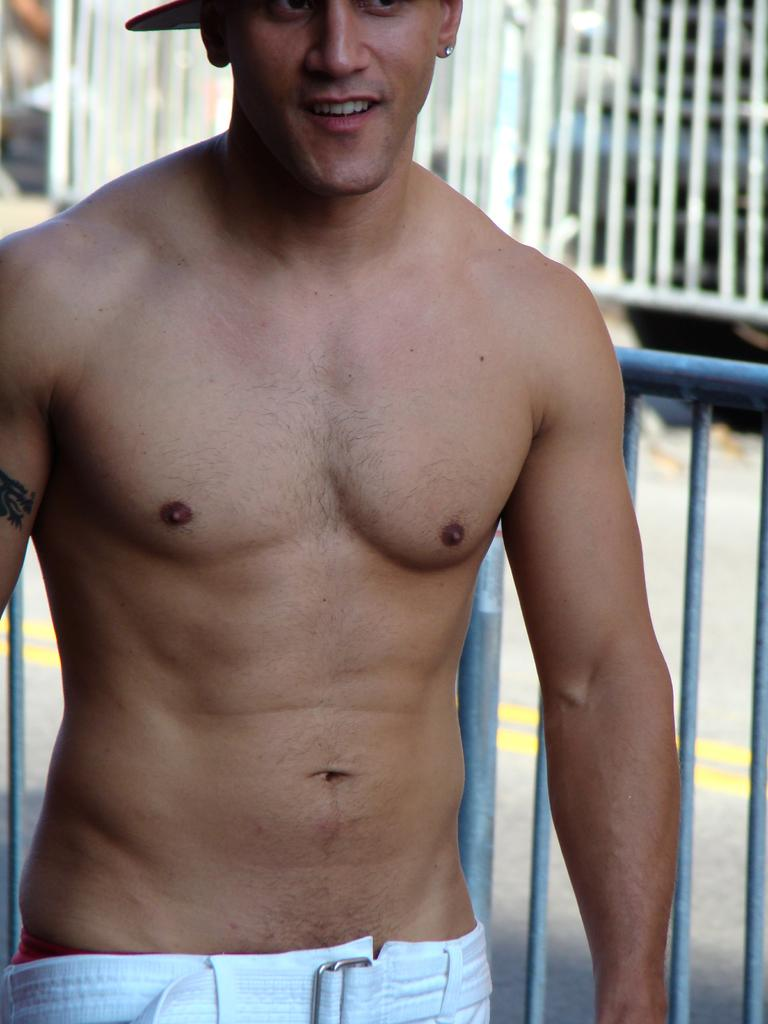What is the main subject in the image? There is a person standing in the image. Can you describe the person's attire? The person is wearing a cap. What is located behind the person? There is a fence behind the person. What can be seen on the right side of the image? There is a road on the right side of the image. What is beside the person? There is a fence beside the person. What type of collar is the person wearing in the image? The person is not wearing a collar in the image; they are wearing a cap. What kind of structure can be seen in the background of the image? There is no specific structure mentioned in the provided facts, so it cannot be determined from the image. 